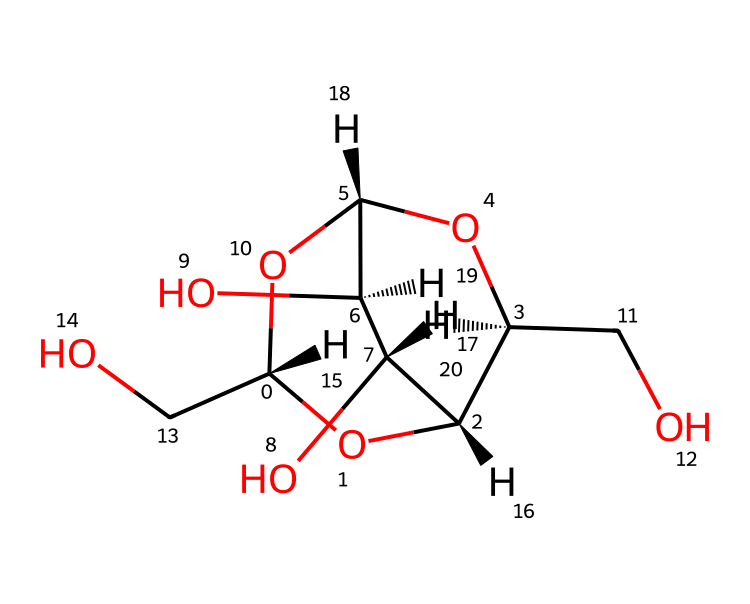What is the name of this chemical? This chemical has a structure that corresponds to cellulose, which is a polysaccharide made of glucose units and is a primary component of plant cell walls.
Answer: cellulose How many carbon atoms are in this structure? By analyzing the SMILES representation, there are six distinct carbon atoms present in the cyclic and branched structure of cellulose.
Answer: six What functional groups are present in this chemical? The structure includes several hydroxyl (–OH) groups, which are characteristic functional groups in carbohydrates, particularly in cellulose.
Answer: hydroxyl Is this chemical soluble in water? Due to the presence of multiple hydroxyl groups that can form hydrogen bonds with water molecules, cellulose is partially soluble in water.
Answer: partially soluble What type of carbohydrate is cellulose classified as? Cellulose is classified as a structural polysaccharide because it provides rigidity and structural support in plant cells.
Answer: structural polysaccharide How many oxygen atoms are in this molecule? Upon inspection of the structure, there are three oxygen atoms that are part of the hydroxyl groups and ether linkages in cellulose.
Answer: three What is the main use of cellulose in historical paper production? Cellulose serves as the main structural material in paper, contributing to its durability and strength, making it essential in historical cartography.
Answer: durability 